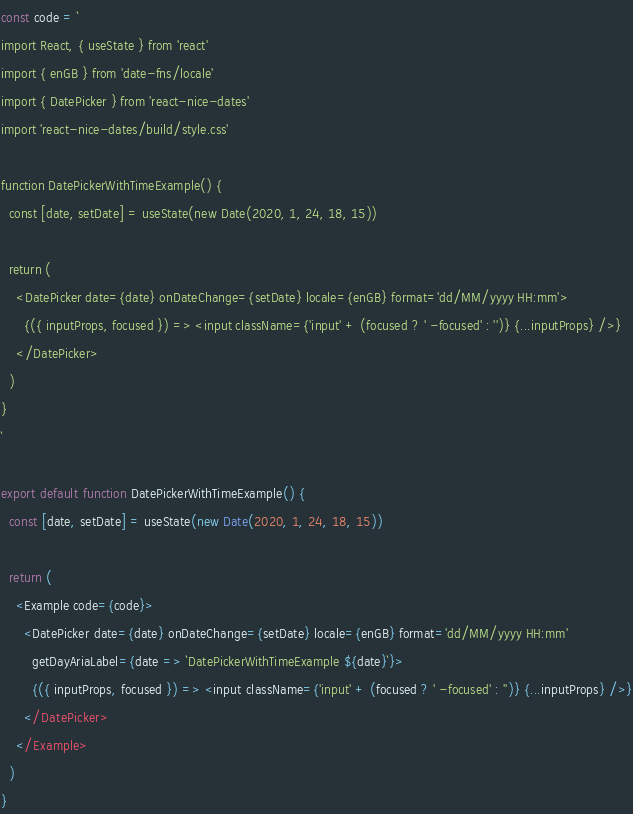<code> <loc_0><loc_0><loc_500><loc_500><_JavaScript_>const code = `
import React, { useState } from 'react'
import { enGB } from 'date-fns/locale'
import { DatePicker } from 'react-nice-dates'
import 'react-nice-dates/build/style.css'

function DatePickerWithTimeExample() {
  const [date, setDate] = useState(new Date(2020, 1, 24, 18, 15))

  return (
    <DatePicker date={date} onDateChange={setDate} locale={enGB} format='dd/MM/yyyy HH:mm'>
      {({ inputProps, focused }) => <input className={'input' + (focused ? ' -focused' : '')} {...inputProps} />}
    </DatePicker>
  )
}
`

export default function DatePickerWithTimeExample() {
  const [date, setDate] = useState(new Date(2020, 1, 24, 18, 15))

  return (
    <Example code={code}>
      <DatePicker date={date} onDateChange={setDate} locale={enGB} format='dd/MM/yyyy HH:mm'
        getDayAriaLabel={date => `DatePickerWithTimeExample ${date}`}>
        {({ inputProps, focused }) => <input className={'input' + (focused ? ' -focused' : '')} {...inputProps} />}
      </DatePicker>
    </Example>
  )
}
</code> 